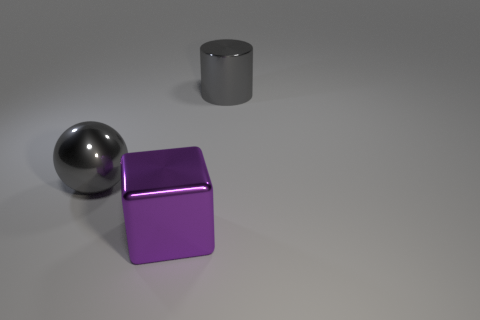How do the objects' textures differ from each other? The objects feature distinct textures: the cylinder and sphere have reflective metallic surfaces, while the cube has a matte finish that diffuses light over its surface. What is the possible material of the purple cube? The purple cube appears to be made of a material with a satiny finish, which could suggest it's made of a matte metal or a plastic with a unique sheen. 